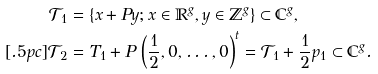Convert formula to latex. <formula><loc_0><loc_0><loc_500><loc_500>\mathcal { T } _ { 1 } & = \{ x + P y ; x \in \mathbb { R } ^ { g } , y \in \mathbb { Z } ^ { g } \} \subset \mathbb { C } ^ { g } , \\ [ . 5 p c ] \mathcal { T } _ { 2 } & = T _ { 1 } + P \, \left ( \frac { 1 } { 2 } , 0 , \dots , 0 \right ) ^ { t } = \mathcal { T } _ { 1 } + \frac { 1 } { 2 } p _ { 1 } \subset \mathbb { C } ^ { g } .</formula> 